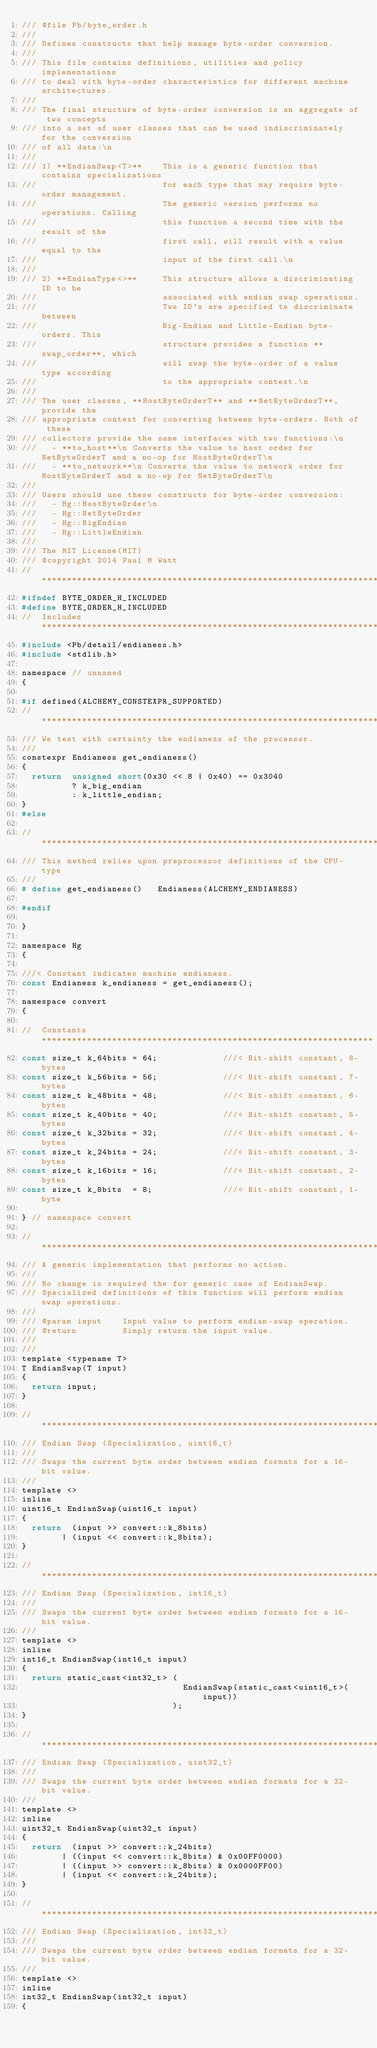<code> <loc_0><loc_0><loc_500><loc_500><_C_>/// @file Pb/byte_order.h
/// 
/// Defines constructs that help manage byte-order conversion.
/// 
/// This file contains definitions, utilities and policy implementations
/// to deal with byte-order characteristics for different machine architectures.
/// 
/// The final structure of byte-order conversion is an aggregate of two concepts 
/// into a set of user classes that can be used indiscriminately for the conversion
/// of all data:\n
/// 
/// 1) **EndianSwap<T>**    This is a generic function that contains specializations
///                         for each type that may require byte-order management.
///                         The generic version performs no operations. Calling
///                         this function a second time with the result of the
///                         first call, will result with a value equal to the 
///                         input of the first call.\n
///                         
/// 2) **EndianType<>**     This structure allows a discriminating ID to be 
///                         associated with endian swap operations. 
///                         Two ID's are specified to discriminate between 
///                         Big-Endian and Little-Endian byte-orders. This 
///                         structure provides a function **swap_order**, which
///                         will swap the byte-order of a value type according
///                         to the appropriate context.\n
///           
/// The user classes, **HostByteOrderT** and **NetByteOrderT**, provide the 
/// appropriate context for converting between byte-orders. Both of these 
/// collectors provide the same interfaces with two functions:\n
///   - **to_host**\n Converts the value to host order for NetByteOrderT and a no-op for HostByteOrderT\n
///   - **to_network**\n Converts the value to network order for HostByteOrderT and a no-op for NetByteOrderT\n
/// 
/// Users should use these constructs for byte-order conversion:
///   - Hg::HostByteOrder\n
///   - Hg::NetByteOrder
///   - Hg::BigEndian
///   - Hg::LittleEndian
/// 
/// The MIT License(MIT)
/// @copyright 2014 Paul M Watt
//  ****************************************************************************
#ifndef BYTE_ORDER_H_INCLUDED
#define BYTE_ORDER_H_INCLUDED
//  Includes *******************************************************************
#include <Pb/detail/endianess.h>
#include <stdlib.h>

namespace // unnamed
{

#if defined(ALCHEMY_CONSTEXPR_SUPPORTED)
//  ****************************************************************************
/// We test with certainty the endianess of the processor.
///
constexpr Endianess get_endianess()
{
  return  unsigned short(0x30 << 8 | 0x40) == 0x3040
          ? k_big_endian
          : k_little_endian;
}
#else

//  ****************************************************************************
/// This method relies upon preprocessor definitions of the CPU-type
///
# define get_endianess()   Endianess(ALCHEMY_ENDIANESS)

#endif

}

namespace Hg
{

///< Constant indicates machine endianess.
const Endianess k_endianess = get_endianess();

namespace convert
{

//  Constants ******************************************************************
const size_t k_64bits = 64;             ///< Bit-shift constant, 8-bytes
const size_t k_56bits = 56;             ///< Bit-shift constant, 7-bytes
const size_t k_48bits = 48;             ///< Bit-shift constant, 6-bytes
const size_t k_40bits = 40;             ///< Bit-shift constant, 5-bytes
const size_t k_32bits = 32;             ///< Bit-shift constant, 4-bytes
const size_t k_24bits = 24;             ///< Bit-shift constant, 3-bytes
const size_t k_16bits = 16;             ///< Bit-shift constant, 2-bytes
const size_t k_8bits  = 8;              ///< Bit-shift constant, 1-byte

} // namespace convert

//  ****************************************************************************
/// A generic implementation that performs no action.
/// 
/// No change is required the for generic case of EndianSwap.
/// Specialized definitions of this function will perform endian swap operations.
///
/// @param input    Input value to perform endian-swap operation.
/// @return         Simply return the input value.  
/// 
///
template <typename T>
T EndianSwap(T input)
{
  return input;
}

//  ****************************************************************************
/// Endian Swap (Specialization, uint16_t) 
/// 
/// Swaps the current byte order between endian formats for a 16-bit value.  
///
template <>
inline
uint16_t EndianSwap(uint16_t input)
{
  return  (input >> convert::k_8bits)
        | (input << convert::k_8bits);
}

//  ****************************************************************************
/// Endian Swap (Specialization, int16_t) 
/// 
/// Swaps the current byte order between endian formats for a 16-bit value.  
///
template <>
inline
int16_t EndianSwap(int16_t input)
{
  return static_cast<int32_t> (
                                EndianSwap(static_cast<uint16_t>(input))
                              );
}

//  ****************************************************************************
/// Endian Swap (Specialization, uint32_t) 
/// 
/// Swaps the current byte order between endian formats for a 32-bit value.
/// 
template <>
inline
uint32_t EndianSwap(uint32_t input)
{
  return  (input >> convert::k_24bits)
        | ((input << convert::k_8bits) & 0x00FF0000)
        | ((input >> convert::k_8bits) & 0x0000FF00)
        | (input << convert::k_24bits);
}

//  ****************************************************************************
/// Endian Swap (Specialization, int32_t) 
/// 
/// Swaps the current byte order between endian formats for a 32-bit value.  
///
template <>
inline
int32_t EndianSwap(int32_t input)
{</code> 